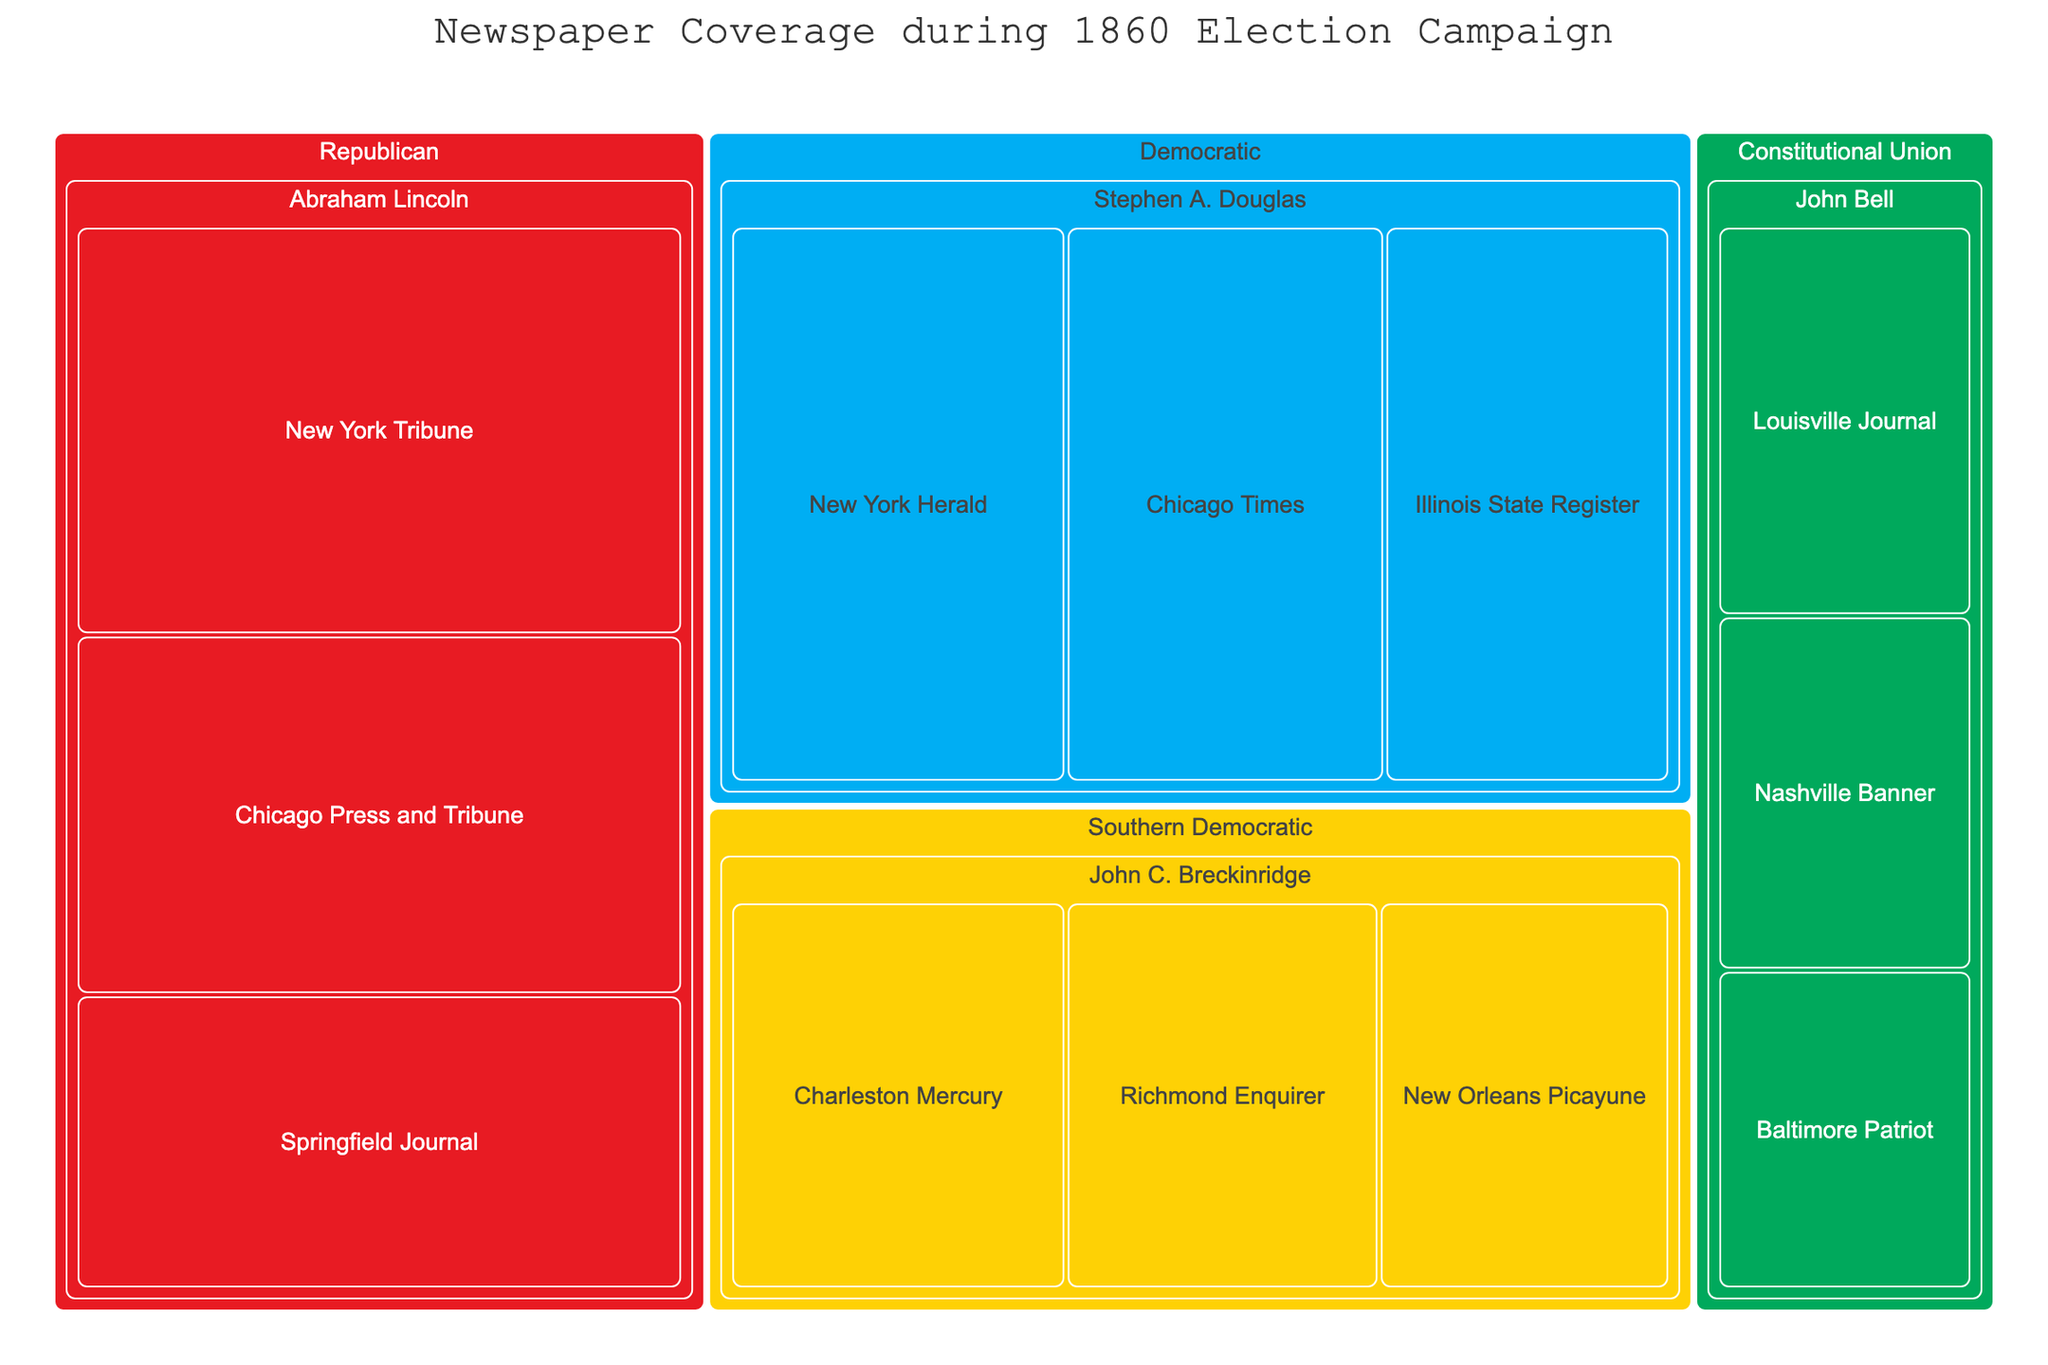What is the total newspaper coverage for Abraham Lincoln? To find the total coverage for Abraham Lincoln, sum up the coverage inches for each newspaper that supported him: 2500 (New York Tribune) + 2200 (Chicago Press and Tribune) + 1800 (Springfield Journal). Thus, the total coverage is 2500 + 2200 + 1800 = 6500 inches.
Answer: 6500 inches Which candidate had the highest individual newspaper coverage, and what was the value? Look at the coverage inches for each newspaper and find the highest value: Abraham Lincoln (2500, 2200, 1800), Stephen A. Douglas (2000, 1900, 1700), John C. Breckinridge (1500, 1400, 1300), John Bell (1100, 1000, 900). The highest individual coverage is 2500 inches by the New York Tribune for Abraham Lincoln.
Answer: Abraham Lincoln, 2500 inches Which party had the largest overall newspaper coverage? Sum up the coverage inches for each party. Republican: 6500, Democratic: 5600, Southern Democratic: 4200, Constitutional Union: 3000. Compare the totals to determine which is largest. The Republican Party had the largest overall coverage with 6500 inches.
Answer: Republican Party How does the average newspaper coverage for Stephen A. Douglas compare to that of John C. Breckinridge? Calculate the average coverage for each. Douglas: (2000 + 1900 + 1700) / 3 = 1866.67 inches. Breckinridge: (1500 + 1400 + 1300) / 3 = 1400 inches. Compare the two averages: 1866.67 inches is greater than 1400 inches.
Answer: 1866.67 inches vs. 1400 inches Which candidate received the least total newspaper coverage, and what was the amount? Calculate the total coverage for each candidate: Lincoln: 6500, Douglas: 5600, Breckinridge: 4200, Bell: 3000. The candidate with the least coverage is John Bell with 3000 inches.
Answer: John Bell, 3000 inches How many newspapers covered John C. Breckinridge's campaign? Count the number of newspapers listed under John C. Breckinridge: Charleston Mercury, Richmond Enquirer, New Orleans Picayune. There are 3 newspapers.
Answer: 3 newspapers Which newspaper provided the least coverage for any candidate and what was the value? Look for the smallest coverage value among all newspapers: 900 inches (Baltimore Patriot for John Bell).
Answer: Baltimore Patriot, 900 inches Compare the total coverage inches between the Chicago newspapers of Lincoln and Douglas. Who had more? Sum up the coverage for Lincoln (Chicago Press and Tribune: 2200) and Douglas (Chicago Times: 1900). Lincoln: 2200, Douglas: 1900. Lincoln had more coverage.
Answer: Lincoln, 2200 inches vs. 1900 inches 